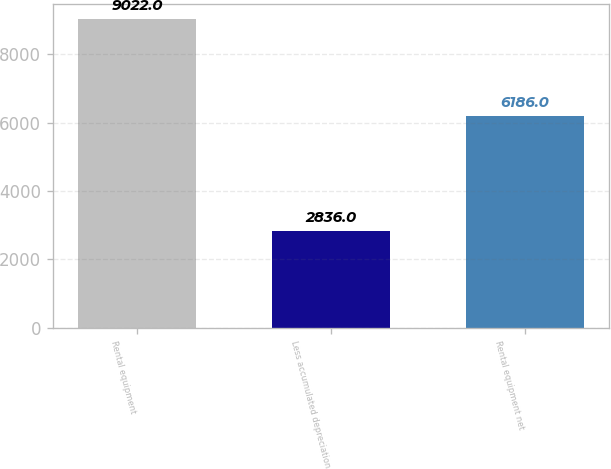Convert chart. <chart><loc_0><loc_0><loc_500><loc_500><bar_chart><fcel>Rental equipment<fcel>Less accumulated depreciation<fcel>Rental equipment net<nl><fcel>9022<fcel>2836<fcel>6186<nl></chart> 